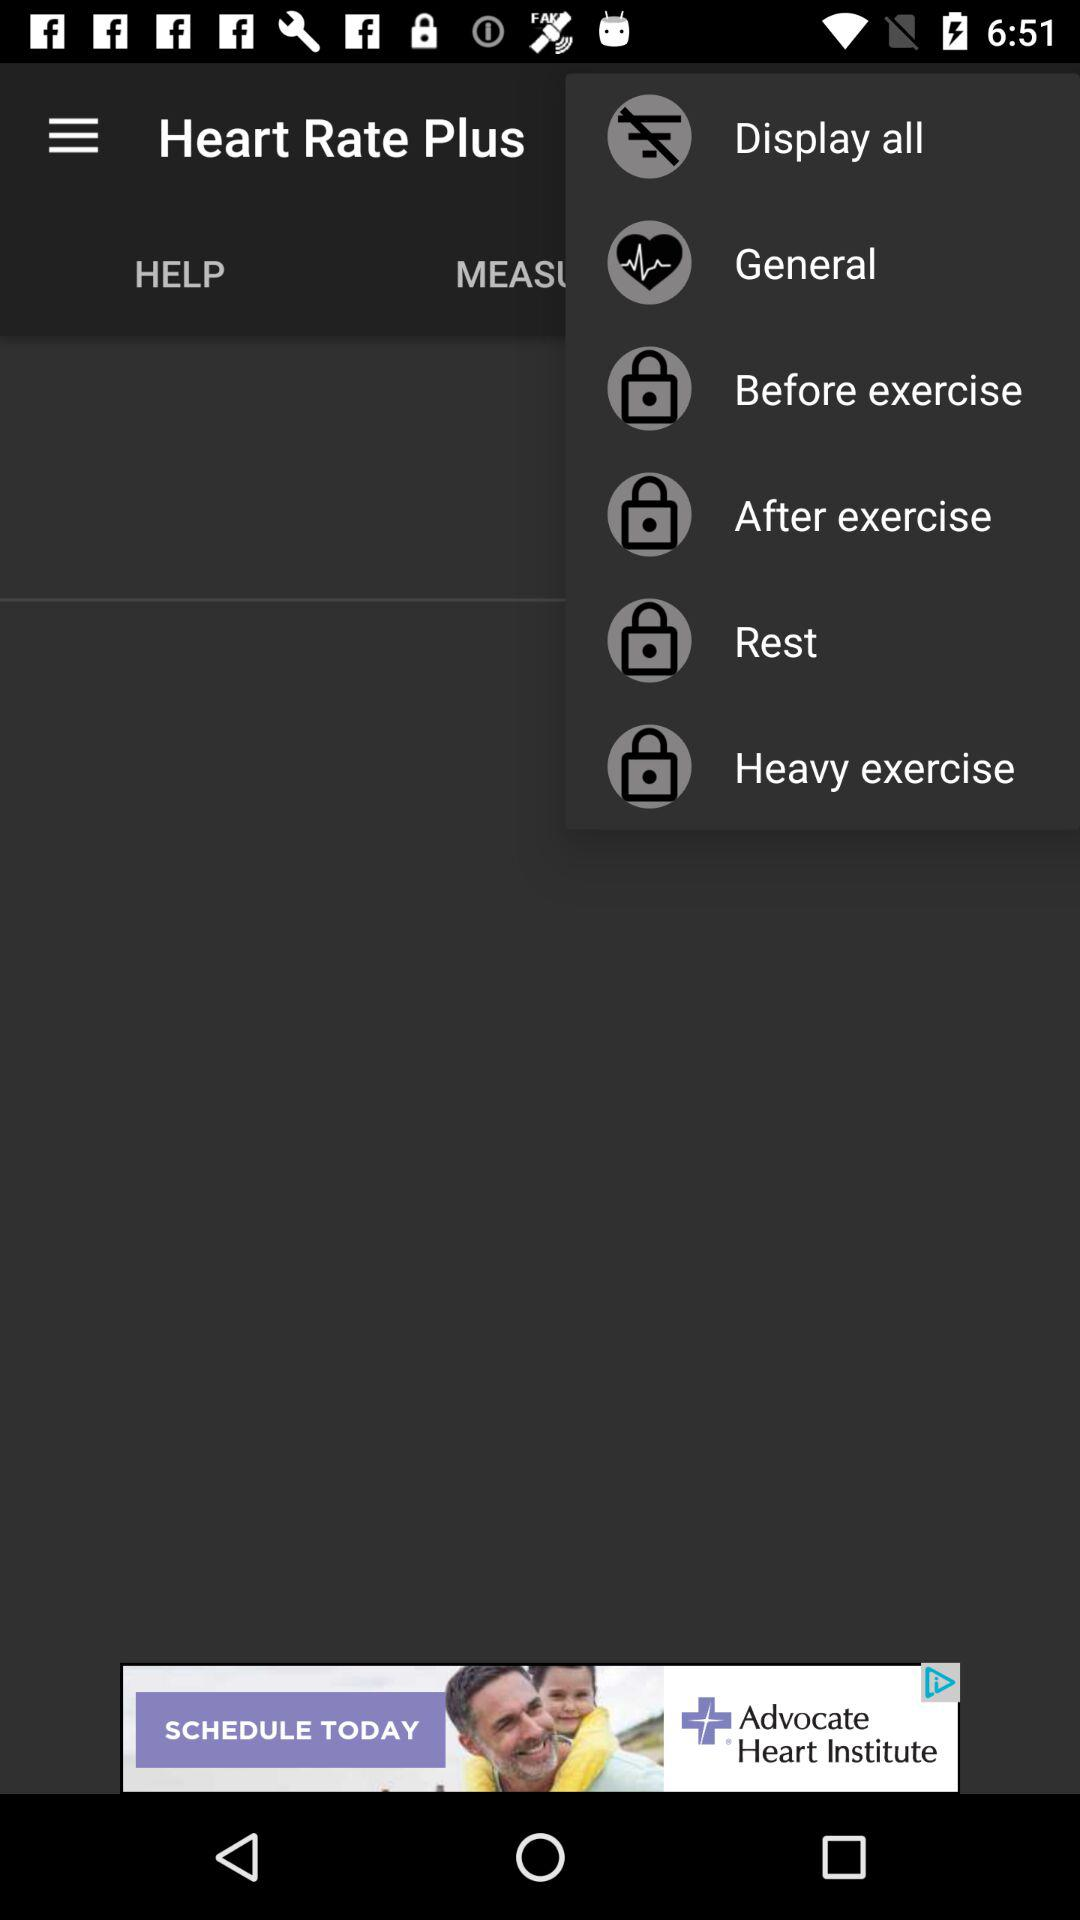What is the user's name?
When the provided information is insufficient, respond with <no answer>. <no answer> 